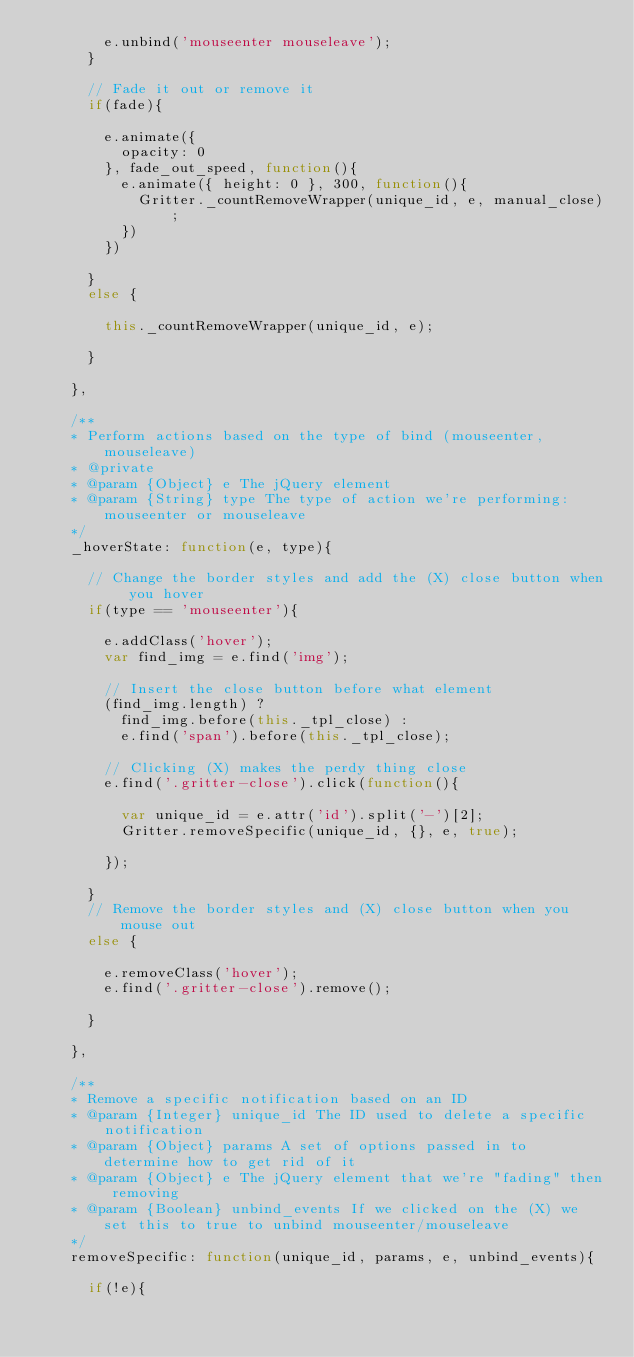<code> <loc_0><loc_0><loc_500><loc_500><_JavaScript_>				e.unbind('mouseenter mouseleave');
			}
			
			// Fade it out or remove it
			if(fade){
			
				e.animate({
					opacity: 0
				}, fade_out_speed, function(){
					e.animate({ height: 0 }, 300, function(){
						Gritter._countRemoveWrapper(unique_id, e, manual_close);
					})
				})
				
			}
			else {
				
				this._countRemoveWrapper(unique_id, e);
				
			}
					    
		},
		
		/**
		* Perform actions based on the type of bind (mouseenter, mouseleave) 
		* @private
		* @param {Object} e The jQuery element
		* @param {String} type The type of action we're performing: mouseenter or mouseleave
		*/
		_hoverState: function(e, type){
			
			// Change the border styles and add the (X) close button when you hover
			if(type == 'mouseenter'){
		    	
				e.addClass('hover');
				var find_img = e.find('img');
		    	
				// Insert the close button before what element
				(find_img.length) ? 
					find_img.before(this._tpl_close) : 
					e.find('span').before(this._tpl_close);
				
				// Clicking (X) makes the perdy thing close
				e.find('.gritter-close').click(function(){
				
					var unique_id = e.attr('id').split('-')[2];
					Gritter.removeSpecific(unique_id, {}, e, true);
					
				});
			
			}
			// Remove the border styles and (X) close button when you mouse out
			else {
				
				e.removeClass('hover');
				e.find('.gritter-close').remove();
				
			}
		    
		},
		
		/**
		* Remove a specific notification based on an ID
		* @param {Integer} unique_id The ID used to delete a specific notification
		* @param {Object} params A set of options passed in to determine how to get rid of it
		* @param {Object} e The jQuery element that we're "fading" then removing
		* @param {Boolean} unbind_events If we clicked on the (X) we set this to true to unbind mouseenter/mouseleave
		*/
		removeSpecific: function(unique_id, params, e, unbind_events){
			
			if(!e){</code> 